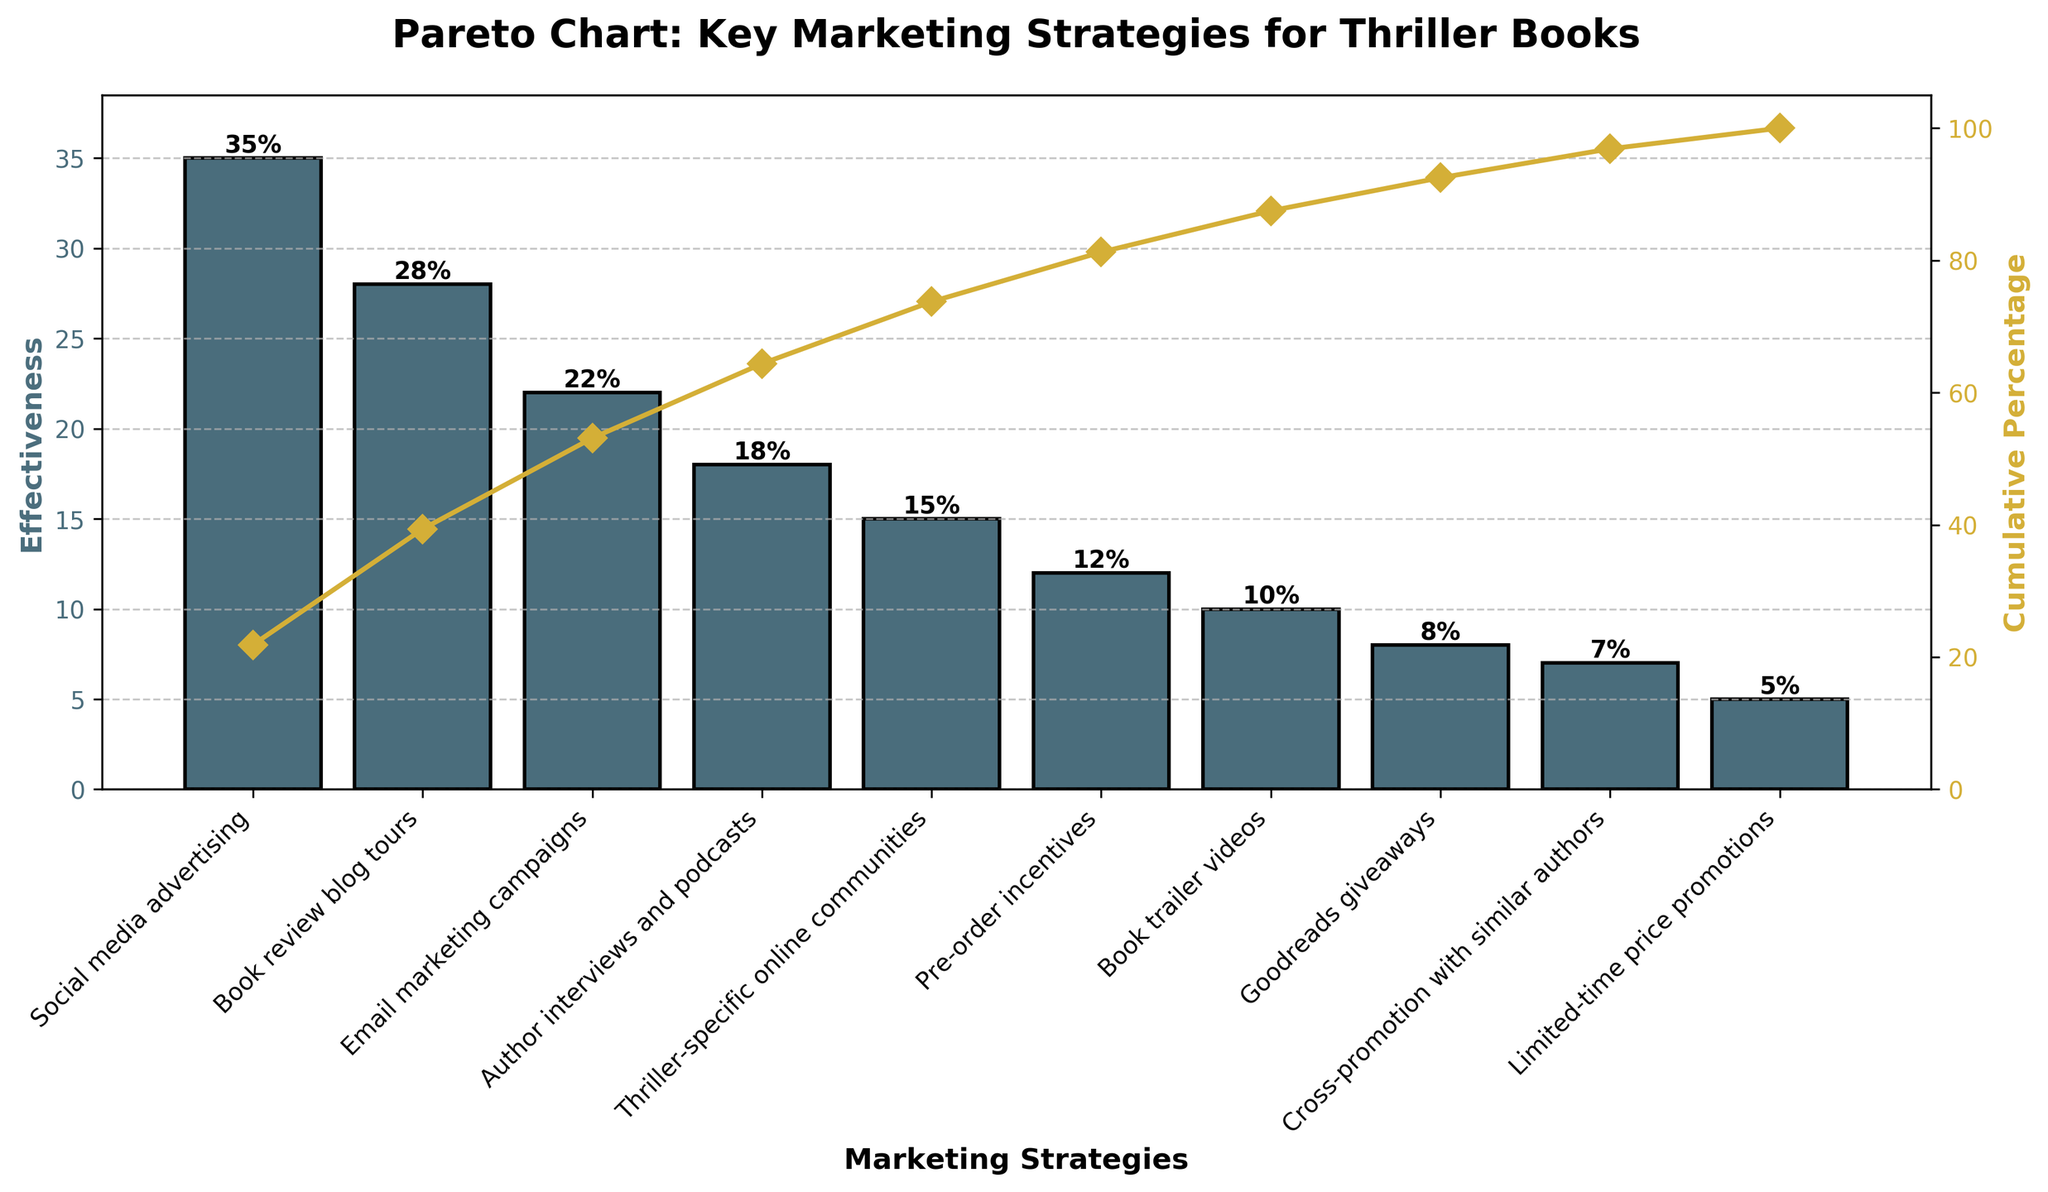What is the title of the chart? The title of the chart is shown at the top and reads "Pareto Chart: Key Marketing Strategies for Thriller Books".
Answer: Pareto Chart: Key Marketing Strategies for Thriller Books Which marketing strategy is depicted as the most effective? The tallest bar represents the most effective marketing strategy, which is listed first in the legend.
Answer: Social media advertising How much more effective is social media advertising compared to email marketing campaigns? The effectiveness of social media advertising is 35, and that of email marketing campaigns is 22. The difference is 35 - 22.
Answer: 13 What is the cumulative percentage effectiveness after accounting for the top three strategies? The cumulative percentages for the top three strategies are shown in the line graph. The cumulative effectiveness percentages for social media advertising, book review blog tours, and email marketing campaigns are summed up.
Answer: 85% Which marketing strategies have an effectiveness lower than 10%? By examining the bars with heights below 10 on the y-axis, we can identify the relevant strategies.
Answer: Goodreads giveaways, Cross-promotion with similar authors, Limited-time price promotions Which strategy ranks just above limited-time price promotions in terms of effectiveness? The strategy immediately preceding limited-time price promotions based on bar height is identified.
Answer: Cross-promotion with similar authors What is the cumulative effectiveness of author interviews and podcasts? The cumulative percentage at the point corresponding to author interviews and podcasts in the cumulative line graph is noted.
Answer: 85% How many strategies have an effectiveness of at least 20%? Bar heights equal to or greater than 20 on the y-axis indicate the number of such strategies.
Answer: 3 What percentage of total effectiveness is accounted for by the two least effective strategies combined? The effectiveness percentages of the two smallest bars (Limited-time price promotions: 5 and Cross-promotion with similar authors: 7) are summed up and divided by the total, then multiplied by 100.
Answer: 12% Which strategies contribute to reaching the 100% effectiveness mark in the cumulative percentage line plot? By following the cumulative percentage line graph, list the strategies until the cumulative percentage reaches or exceeds 100%.
Answer: All strategies 